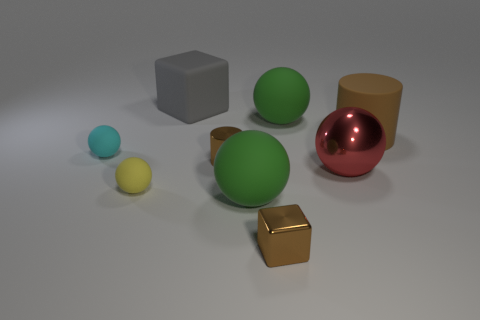What is the shape of the small cyan thing that is the same material as the big gray thing?
Offer a terse response. Sphere. What number of brown things are tiny cylinders or matte cylinders?
Provide a short and direct response. 2. Are there any tiny shiny objects behind the brown cube?
Your response must be concise. Yes. Is the shape of the tiny yellow object that is in front of the matte cylinder the same as the green object behind the big brown cylinder?
Ensure brevity in your answer.  Yes. What material is the other brown object that is the same shape as the big brown thing?
Your response must be concise. Metal. What number of blocks are either blue matte objects or tiny yellow rubber things?
Offer a very short reply. 0. What number of yellow objects have the same material as the large red sphere?
Offer a terse response. 0. Are the block in front of the large gray matte cube and the green object that is in front of the brown metallic cylinder made of the same material?
Make the answer very short. No. There is a small metal object that is behind the cube that is in front of the tiny cyan rubber sphere; what number of brown cylinders are in front of it?
Give a very brief answer. 0. Is the color of the cylinder in front of the cyan rubber thing the same as the tiny object that is on the right side of the small brown metallic cylinder?
Provide a succinct answer. Yes. 